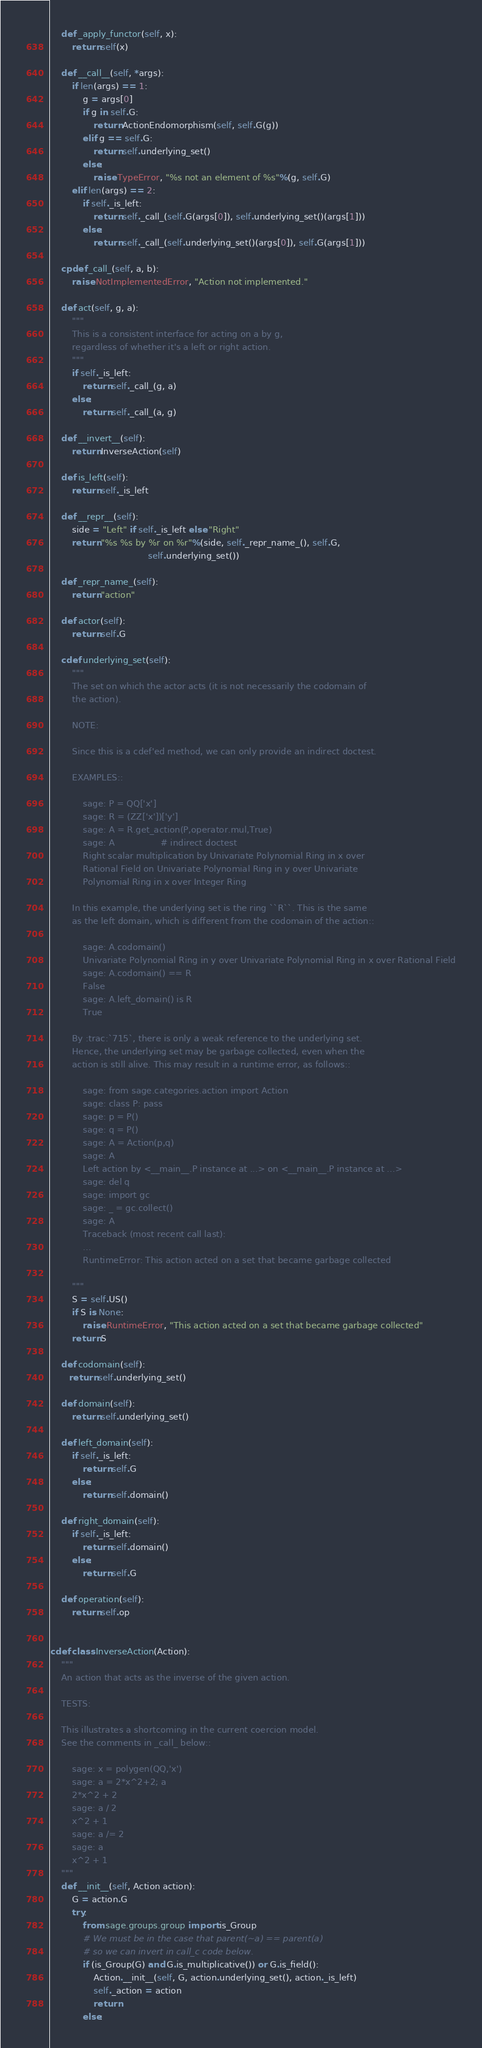Convert code to text. <code><loc_0><loc_0><loc_500><loc_500><_Cython_>    def _apply_functor(self, x):
        return self(x)

    def __call__(self, *args):
        if len(args) == 1:
            g = args[0]
            if g in self.G:
                return ActionEndomorphism(self, self.G(g))
            elif g == self.G:
                return self.underlying_set()
            else:
                raise TypeError, "%s not an element of %s"%(g, self.G)
        elif len(args) == 2:
            if self._is_left:
                return self._call_(self.G(args[0]), self.underlying_set()(args[1]))
            else:
                return self._call_(self.underlying_set()(args[0]), self.G(args[1]))

    cpdef _call_(self, a, b):
        raise NotImplementedError, "Action not implemented."

    def act(self, g, a):
        """
        This is a consistent interface for acting on a by g,
        regardless of whether it's a left or right action.
        """
        if self._is_left:
            return self._call_(g, a)
        else:
            return self._call_(a, g)

    def __invert__(self):
        return InverseAction(self)

    def is_left(self):
        return self._is_left

    def __repr__(self):
        side = "Left" if self._is_left else "Right"
        return "%s %s by %r on %r"%(side, self._repr_name_(), self.G,
                                    self.underlying_set())

    def _repr_name_(self):
        return "action"

    def actor(self):
        return self.G

    cdef underlying_set(self):
        """
        The set on which the actor acts (it is not necessarily the codomain of
        the action).

        NOTE:

        Since this is a cdef'ed method, we can only provide an indirect doctest.

        EXAMPLES::

            sage: P = QQ['x']
            sage: R = (ZZ['x'])['y']
            sage: A = R.get_action(P,operator.mul,True)
            sage: A                 # indirect doctest
            Right scalar multiplication by Univariate Polynomial Ring in x over
            Rational Field on Univariate Polynomial Ring in y over Univariate
            Polynomial Ring in x over Integer Ring

        In this example, the underlying set is the ring ``R``. This is the same
        as the left domain, which is different from the codomain of the action::

            sage: A.codomain()
            Univariate Polynomial Ring in y over Univariate Polynomial Ring in x over Rational Field
            sage: A.codomain() == R
            False
            sage: A.left_domain() is R
            True

        By :trac:`715`, there is only a weak reference to the underlying set.
        Hence, the underlying set may be garbage collected, even when the
        action is still alive. This may result in a runtime error, as follows::

            sage: from sage.categories.action import Action
            sage: class P: pass
            sage: p = P()
            sage: q = P()
            sage: A = Action(p,q)
            sage: A
            Left action by <__main__.P instance at ...> on <__main__.P instance at ...>
            sage: del q
            sage: import gc
            sage: _ = gc.collect()
            sage: A
            Traceback (most recent call last):
            ...
            RuntimeError: This action acted on a set that became garbage collected

        """
        S = self.US()
        if S is None:
            raise RuntimeError, "This action acted on a set that became garbage collected"
        return S

    def codomain(self):
       return self.underlying_set()

    def domain(self):
        return self.underlying_set()

    def left_domain(self):
        if self._is_left:
            return self.G
        else:
            return self.domain()

    def right_domain(self):
        if self._is_left:
            return self.domain()
        else:
            return self.G

    def operation(self):
        return self.op


cdef class InverseAction(Action):
    """
    An action that acts as the inverse of the given action.

    TESTS:

    This illustrates a shortcoming in the current coercion model.
    See the comments in _call_ below::

        sage: x = polygen(QQ,'x')
        sage: a = 2*x^2+2; a
        2*x^2 + 2
        sage: a / 2
        x^2 + 1
        sage: a /= 2
        sage: a
        x^2 + 1
    """
    def __init__(self, Action action):
        G = action.G
        try:
            from sage.groups.group import is_Group
            # We must be in the case that parent(~a) == parent(a)
            # so we can invert in call_c code below.
            if (is_Group(G) and G.is_multiplicative()) or G.is_field():
                Action.__init__(self, G, action.underlying_set(), action._is_left)
                self._action = action
                return
            else:</code> 